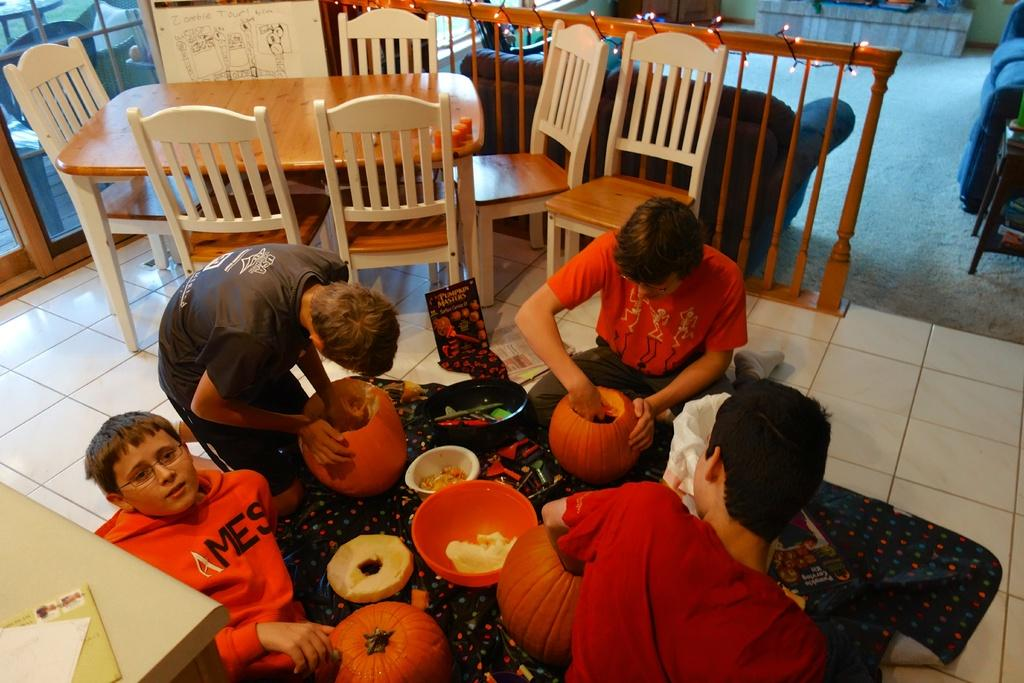What can be seen in the image involving a group of boys? There is a group of boys in the image. What objects related to Halloween can be seen in the image? There are pumpkins in the image. What type of containers are present in the image? There are bowls in the image. What is located on the floor in the image? There is a vessel on the floor in the image. What piece of furniture is present in the image for seating? There are chairs in the image. What type of lighting is present in the image? There is a fence with lights in the image. What type of seating is present in the image for relaxation? There is a sofa in the image. What color is the crayon used to draw on the garden in the image? There is no crayon or garden present in the image. What type of country is depicted in the image? The image does not depict a country; it contains a group of boys, pumpkins, bowls, a vessel, chairs, a fence with lights, and a sofa. 